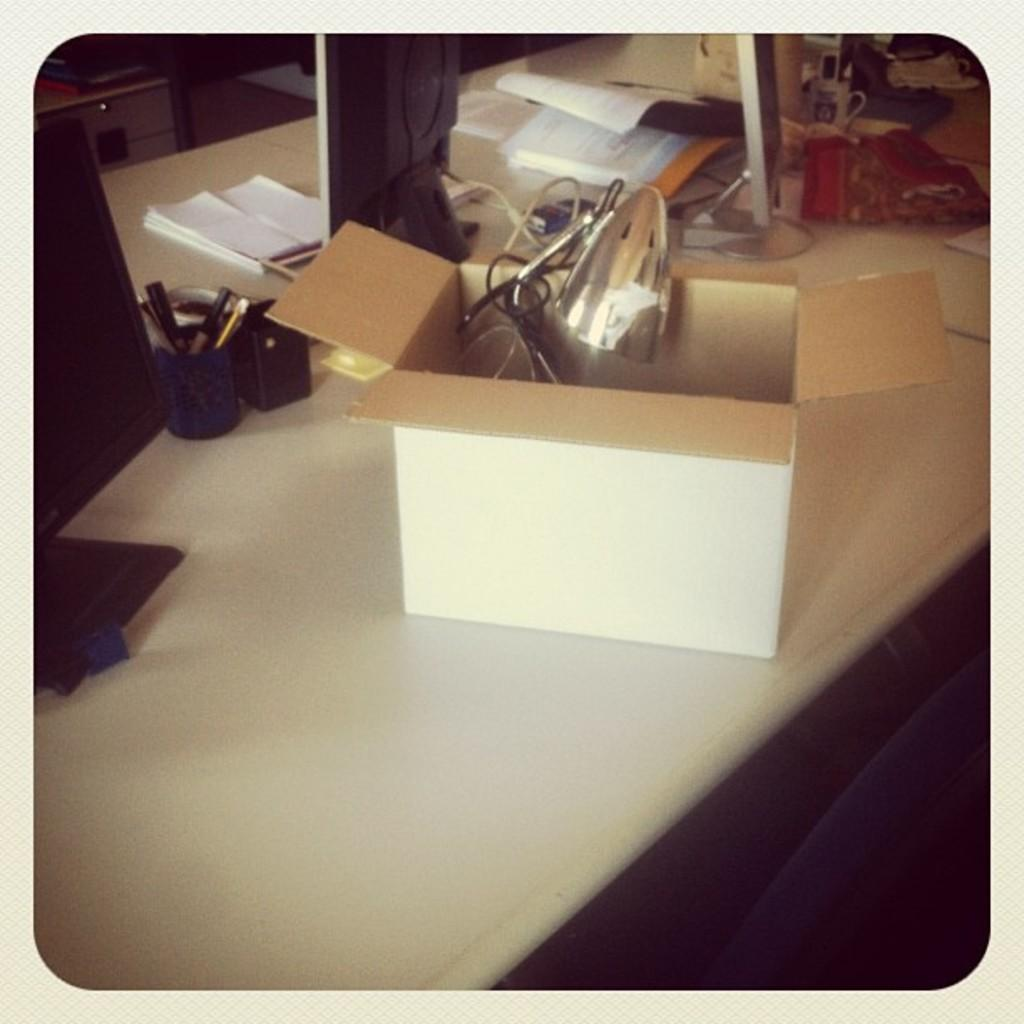What type of furniture is present in the image? There is a table in the image. What is placed on the table? There is a cardboard box and a pen stand on the table. What electronic device is visible in the image? There is a monitor in the image. What type of reading material is present in the image? There are books in the image. Are there any other objects present in the image besides those mentioned? Yes, there are other objects present in the image. Can you see a dad playing with a balloon in the alley in the image? There is no dad, balloon, or alley present in the image. 